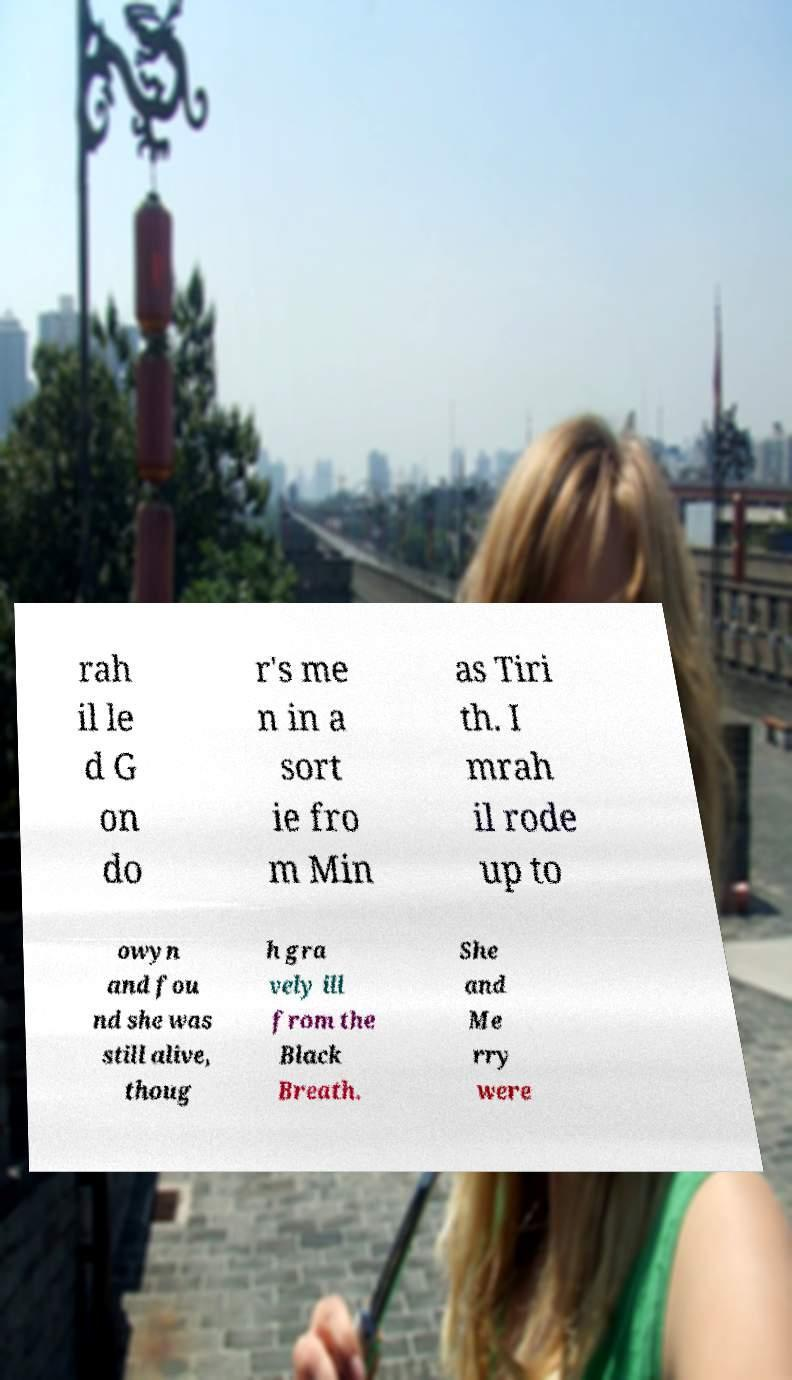Could you extract and type out the text from this image? rah il le d G on do r's me n in a sort ie fro m Min as Tiri th. I mrah il rode up to owyn and fou nd she was still alive, thoug h gra vely ill from the Black Breath. She and Me rry were 